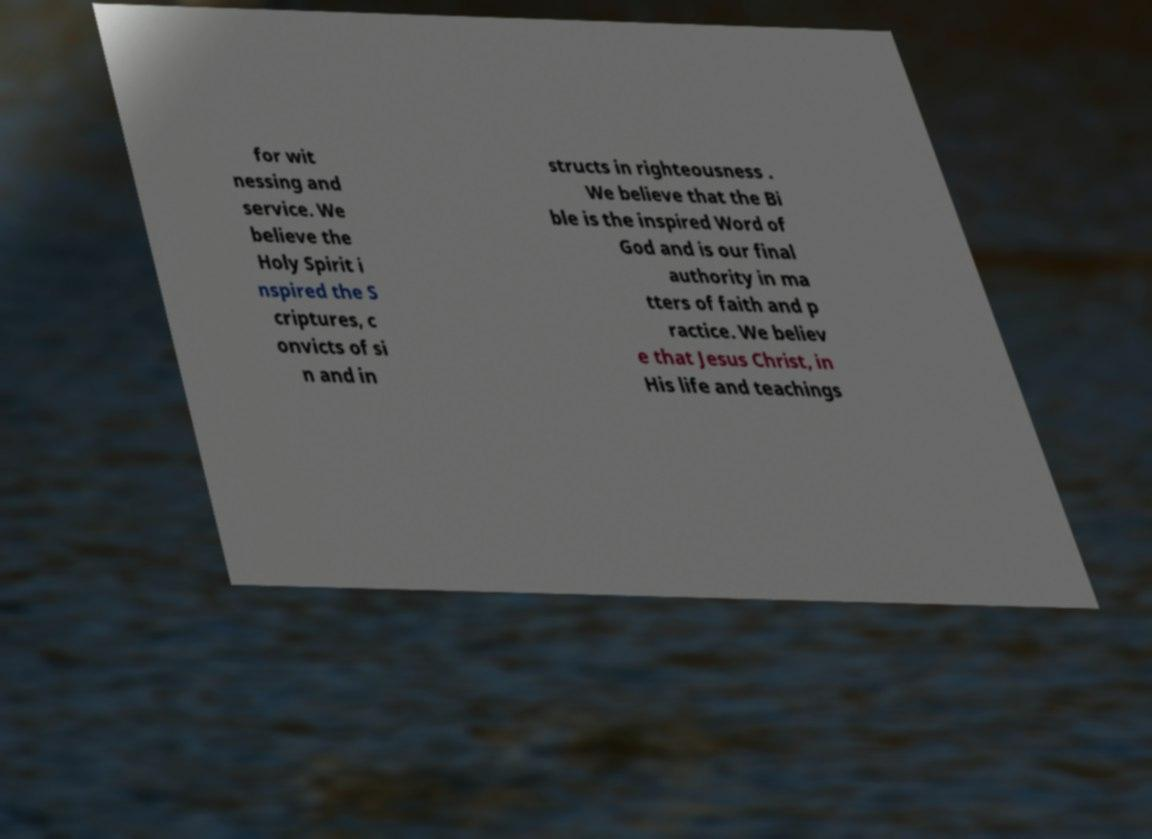For documentation purposes, I need the text within this image transcribed. Could you provide that? for wit nessing and service. We believe the Holy Spirit i nspired the S criptures, c onvicts of si n and in structs in righteousness . We believe that the Bi ble is the inspired Word of God and is our final authority in ma tters of faith and p ractice. We believ e that Jesus Christ, in His life and teachings 